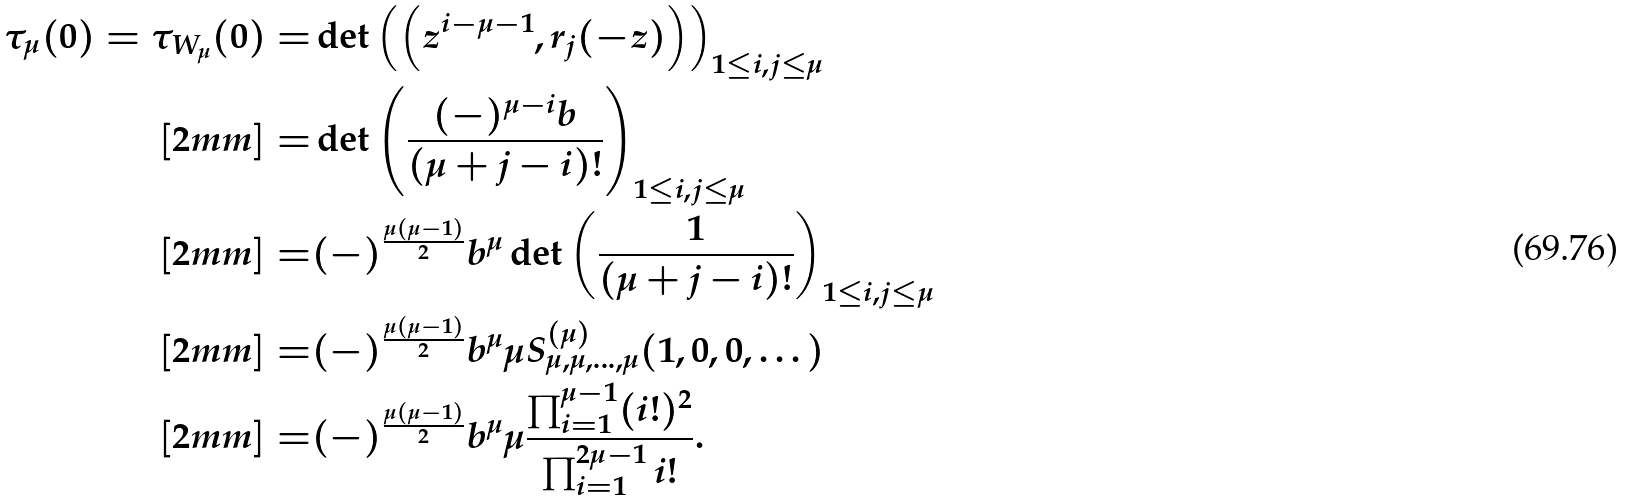Convert formula to latex. <formula><loc_0><loc_0><loc_500><loc_500>\tau _ { \mu } ( 0 ) = \tau _ { W _ { \mu } } ( 0 ) = & \det \left ( \left ( z ^ { i - \mu - 1 } , r _ { j } ( - z ) \right ) \right ) _ { 1 \leq i , j \leq \mu } \\ [ 2 m m ] = & \det \left ( \frac { ( - ) ^ { \mu - i } b } { ( \mu + j - i ) ! } \right ) _ { 1 \leq i , j \leq \mu } \\ [ 2 m m ] = & ( - ) ^ { \frac { \mu ( \mu - 1 ) } { 2 } } b ^ { \mu } \det \left ( \frac { 1 } { ( \mu + j - i ) ! } \right ) _ { 1 \leq i , j \leq \mu } \\ [ 2 m m ] = & ( - ) ^ { \frac { \mu ( \mu - 1 ) } { 2 } } b ^ { \mu } \mu S _ { \mu , \mu , \dots , \mu } ^ { ( \mu ) } ( 1 , 0 , 0 , \dots ) \\ [ 2 m m ] = & ( - ) ^ { \frac { \mu ( \mu - 1 ) } { 2 } } b ^ { \mu } \mu \frac { \prod _ { i = 1 } ^ { \mu - 1 } ( i ! ) ^ { 2 } } { \prod _ { i = 1 } ^ { 2 \mu - 1 } i ! } .</formula> 